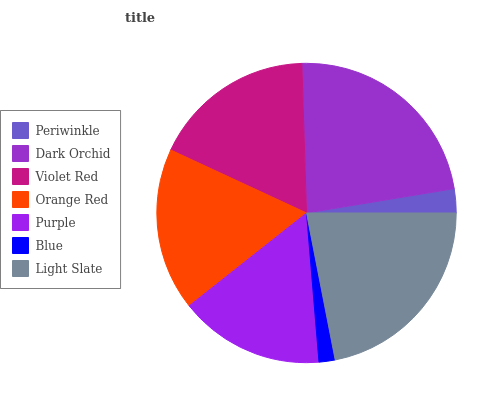Is Blue the minimum?
Answer yes or no. Yes. Is Dark Orchid the maximum?
Answer yes or no. Yes. Is Violet Red the minimum?
Answer yes or no. No. Is Violet Red the maximum?
Answer yes or no. No. Is Dark Orchid greater than Violet Red?
Answer yes or no. Yes. Is Violet Red less than Dark Orchid?
Answer yes or no. Yes. Is Violet Red greater than Dark Orchid?
Answer yes or no. No. Is Dark Orchid less than Violet Red?
Answer yes or no. No. Is Orange Red the high median?
Answer yes or no. Yes. Is Orange Red the low median?
Answer yes or no. Yes. Is Blue the high median?
Answer yes or no. No. Is Light Slate the low median?
Answer yes or no. No. 